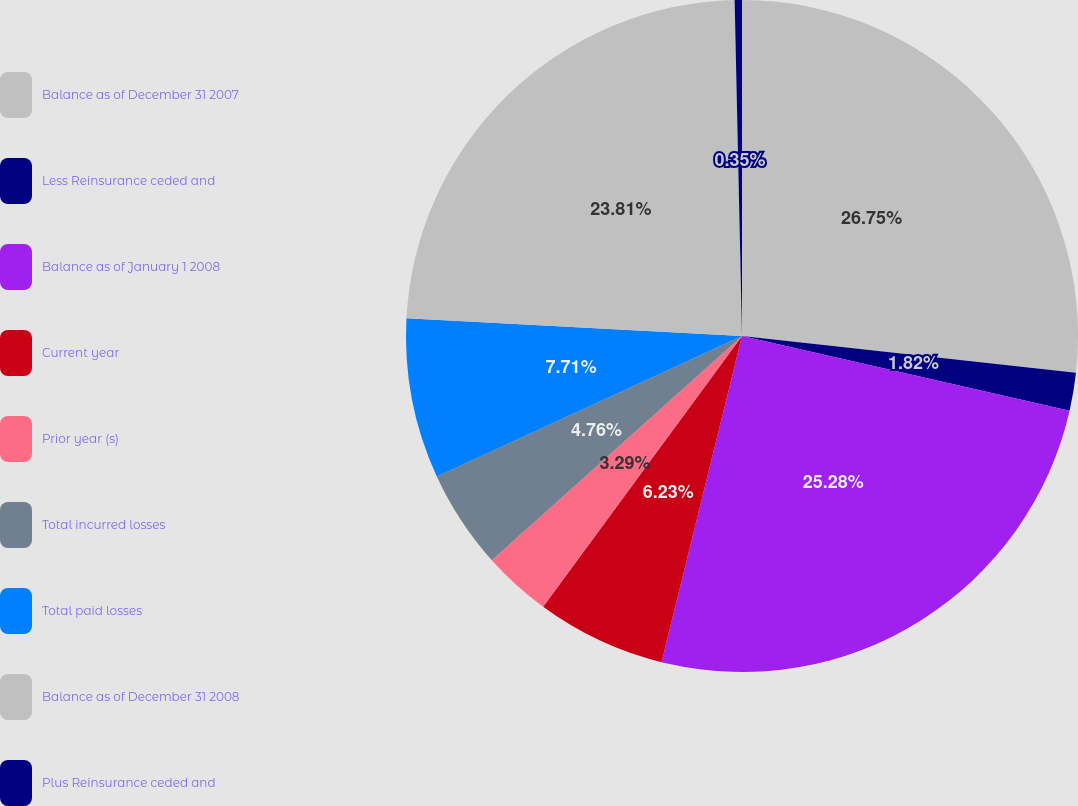Convert chart. <chart><loc_0><loc_0><loc_500><loc_500><pie_chart><fcel>Balance as of December 31 2007<fcel>Less Reinsurance ceded and<fcel>Balance as of January 1 2008<fcel>Current year<fcel>Prior year (s)<fcel>Total incurred losses<fcel>Total paid losses<fcel>Balance as of December 31 2008<fcel>Plus Reinsurance ceded and<nl><fcel>26.75%<fcel>1.82%<fcel>25.28%<fcel>6.23%<fcel>3.29%<fcel>4.76%<fcel>7.71%<fcel>23.81%<fcel>0.35%<nl></chart> 